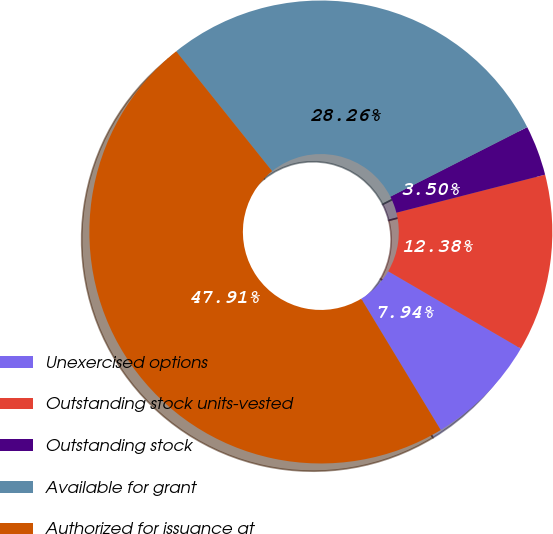Convert chart to OTSL. <chart><loc_0><loc_0><loc_500><loc_500><pie_chart><fcel>Unexercised options<fcel>Outstanding stock units-vested<fcel>Outstanding stock<fcel>Available for grant<fcel>Authorized for issuance at<nl><fcel>7.94%<fcel>12.38%<fcel>3.5%<fcel>28.26%<fcel>47.91%<nl></chart> 